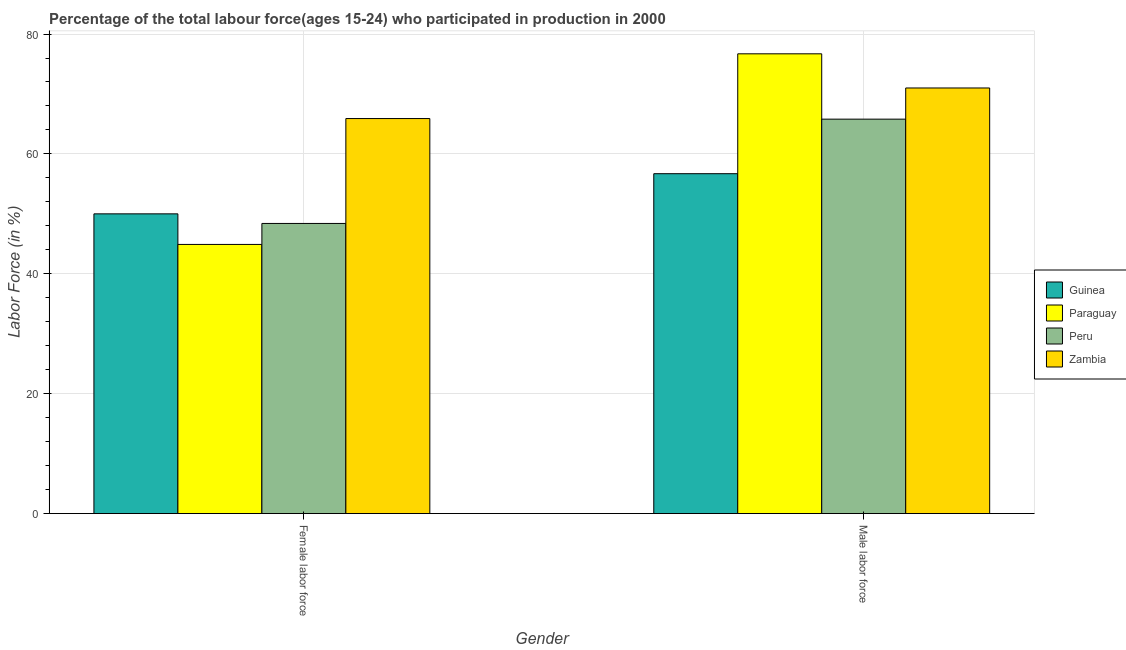Are the number of bars per tick equal to the number of legend labels?
Offer a very short reply. Yes. Are the number of bars on each tick of the X-axis equal?
Make the answer very short. Yes. What is the label of the 1st group of bars from the left?
Offer a terse response. Female labor force. What is the percentage of male labour force in Guinea?
Provide a succinct answer. 56.7. Across all countries, what is the maximum percentage of male labour force?
Ensure brevity in your answer.  76.7. Across all countries, what is the minimum percentage of male labour force?
Make the answer very short. 56.7. In which country was the percentage of male labour force maximum?
Provide a succinct answer. Paraguay. In which country was the percentage of male labour force minimum?
Give a very brief answer. Guinea. What is the total percentage of male labour force in the graph?
Offer a terse response. 270.2. What is the difference between the percentage of male labour force in Paraguay and that in Peru?
Give a very brief answer. 10.9. What is the difference between the percentage of female labor force in Paraguay and the percentage of male labour force in Zambia?
Give a very brief answer. -26.1. What is the average percentage of female labor force per country?
Your answer should be compact. 52.3. What is the difference between the percentage of male labour force and percentage of female labor force in Peru?
Make the answer very short. 17.4. In how many countries, is the percentage of male labour force greater than 56 %?
Ensure brevity in your answer.  4. What is the ratio of the percentage of female labor force in Paraguay to that in Peru?
Provide a short and direct response. 0.93. Is the percentage of female labor force in Guinea less than that in Zambia?
Your response must be concise. Yes. What does the 4th bar from the left in Female labor force represents?
Keep it short and to the point. Zambia. What does the 4th bar from the right in Female labor force represents?
Give a very brief answer. Guinea. Are all the bars in the graph horizontal?
Keep it short and to the point. No. Does the graph contain any zero values?
Your answer should be very brief. No. Does the graph contain grids?
Give a very brief answer. Yes. Where does the legend appear in the graph?
Give a very brief answer. Center right. How many legend labels are there?
Provide a succinct answer. 4. What is the title of the graph?
Your response must be concise. Percentage of the total labour force(ages 15-24) who participated in production in 2000. Does "Panama" appear as one of the legend labels in the graph?
Provide a succinct answer. No. What is the label or title of the X-axis?
Offer a terse response. Gender. What is the Labor Force (in %) in Paraguay in Female labor force?
Keep it short and to the point. 44.9. What is the Labor Force (in %) in Peru in Female labor force?
Make the answer very short. 48.4. What is the Labor Force (in %) of Zambia in Female labor force?
Offer a terse response. 65.9. What is the Labor Force (in %) in Guinea in Male labor force?
Offer a terse response. 56.7. What is the Labor Force (in %) in Paraguay in Male labor force?
Provide a short and direct response. 76.7. What is the Labor Force (in %) of Peru in Male labor force?
Make the answer very short. 65.8. Across all Gender, what is the maximum Labor Force (in %) in Guinea?
Offer a very short reply. 56.7. Across all Gender, what is the maximum Labor Force (in %) of Paraguay?
Your answer should be very brief. 76.7. Across all Gender, what is the maximum Labor Force (in %) in Peru?
Your response must be concise. 65.8. Across all Gender, what is the maximum Labor Force (in %) of Zambia?
Give a very brief answer. 71. Across all Gender, what is the minimum Labor Force (in %) in Paraguay?
Ensure brevity in your answer.  44.9. Across all Gender, what is the minimum Labor Force (in %) in Peru?
Ensure brevity in your answer.  48.4. Across all Gender, what is the minimum Labor Force (in %) of Zambia?
Give a very brief answer. 65.9. What is the total Labor Force (in %) in Guinea in the graph?
Give a very brief answer. 106.7. What is the total Labor Force (in %) of Paraguay in the graph?
Make the answer very short. 121.6. What is the total Labor Force (in %) of Peru in the graph?
Your response must be concise. 114.2. What is the total Labor Force (in %) in Zambia in the graph?
Keep it short and to the point. 136.9. What is the difference between the Labor Force (in %) in Paraguay in Female labor force and that in Male labor force?
Provide a short and direct response. -31.8. What is the difference between the Labor Force (in %) of Peru in Female labor force and that in Male labor force?
Provide a succinct answer. -17.4. What is the difference between the Labor Force (in %) in Guinea in Female labor force and the Labor Force (in %) in Paraguay in Male labor force?
Keep it short and to the point. -26.7. What is the difference between the Labor Force (in %) of Guinea in Female labor force and the Labor Force (in %) of Peru in Male labor force?
Ensure brevity in your answer.  -15.8. What is the difference between the Labor Force (in %) in Paraguay in Female labor force and the Labor Force (in %) in Peru in Male labor force?
Provide a short and direct response. -20.9. What is the difference between the Labor Force (in %) in Paraguay in Female labor force and the Labor Force (in %) in Zambia in Male labor force?
Offer a very short reply. -26.1. What is the difference between the Labor Force (in %) of Peru in Female labor force and the Labor Force (in %) of Zambia in Male labor force?
Keep it short and to the point. -22.6. What is the average Labor Force (in %) of Guinea per Gender?
Your answer should be compact. 53.35. What is the average Labor Force (in %) in Paraguay per Gender?
Offer a very short reply. 60.8. What is the average Labor Force (in %) in Peru per Gender?
Your response must be concise. 57.1. What is the average Labor Force (in %) of Zambia per Gender?
Your answer should be compact. 68.45. What is the difference between the Labor Force (in %) in Guinea and Labor Force (in %) in Paraguay in Female labor force?
Provide a short and direct response. 5.1. What is the difference between the Labor Force (in %) in Guinea and Labor Force (in %) in Zambia in Female labor force?
Your response must be concise. -15.9. What is the difference between the Labor Force (in %) in Peru and Labor Force (in %) in Zambia in Female labor force?
Make the answer very short. -17.5. What is the difference between the Labor Force (in %) of Guinea and Labor Force (in %) of Paraguay in Male labor force?
Ensure brevity in your answer.  -20. What is the difference between the Labor Force (in %) of Guinea and Labor Force (in %) of Zambia in Male labor force?
Offer a terse response. -14.3. What is the difference between the Labor Force (in %) in Paraguay and Labor Force (in %) in Peru in Male labor force?
Your answer should be compact. 10.9. What is the difference between the Labor Force (in %) in Peru and Labor Force (in %) in Zambia in Male labor force?
Provide a short and direct response. -5.2. What is the ratio of the Labor Force (in %) in Guinea in Female labor force to that in Male labor force?
Provide a short and direct response. 0.88. What is the ratio of the Labor Force (in %) in Paraguay in Female labor force to that in Male labor force?
Your answer should be compact. 0.59. What is the ratio of the Labor Force (in %) in Peru in Female labor force to that in Male labor force?
Give a very brief answer. 0.74. What is the ratio of the Labor Force (in %) of Zambia in Female labor force to that in Male labor force?
Ensure brevity in your answer.  0.93. What is the difference between the highest and the second highest Labor Force (in %) of Guinea?
Keep it short and to the point. 6.7. What is the difference between the highest and the second highest Labor Force (in %) of Paraguay?
Keep it short and to the point. 31.8. What is the difference between the highest and the second highest Labor Force (in %) in Peru?
Ensure brevity in your answer.  17.4. What is the difference between the highest and the lowest Labor Force (in %) in Paraguay?
Offer a very short reply. 31.8. What is the difference between the highest and the lowest Labor Force (in %) of Peru?
Your answer should be very brief. 17.4. 